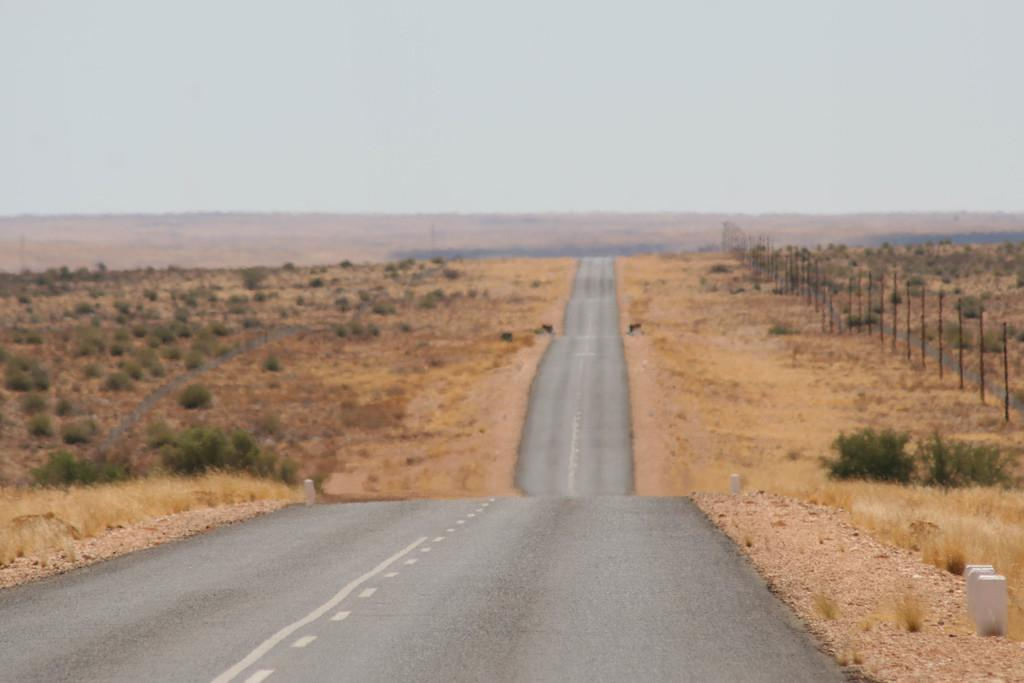What is the main feature of the image? There is a road in the image. What can be seen on both sides of the road? Land and plants are visible on both sides of the road. What type of barrier is present on the right side of the image? There is fencing on the right side of the image. What is visible at the top of the image? The sky is visible at the top of the image. What type of jam is being spread on the fork in the image? There is no fork or jam present in the image. How does the pull of gravity affect the plants on both sides of the road in the image? The image does not show the effects of gravity on the plants; it only shows the plants' static appearance. 